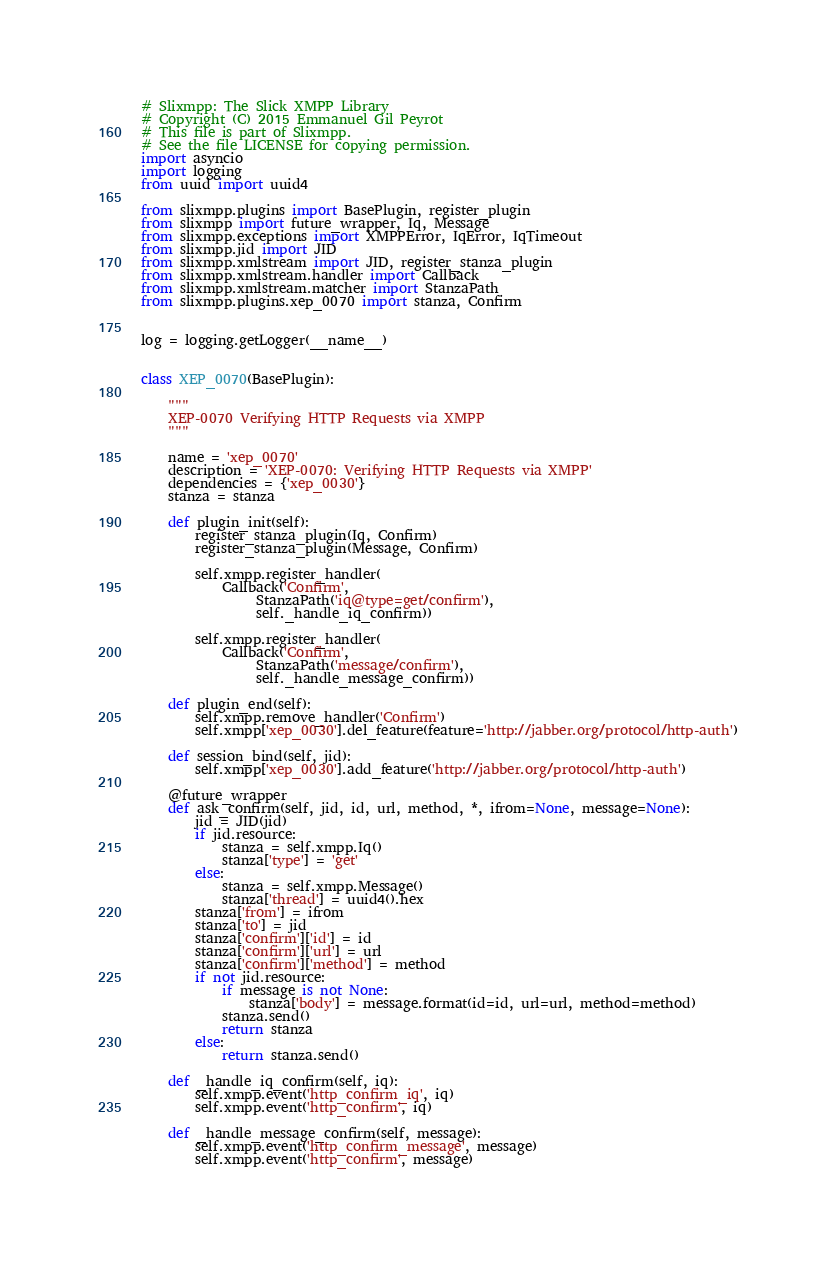Convert code to text. <code><loc_0><loc_0><loc_500><loc_500><_Python_>
# Slixmpp: The Slick XMPP Library
# Copyright (C) 2015 Emmanuel Gil Peyrot
# This file is part of Slixmpp.
# See the file LICENSE for copying permission.
import asyncio
import logging
from uuid import uuid4

from slixmpp.plugins import BasePlugin, register_plugin
from slixmpp import future_wrapper, Iq, Message
from slixmpp.exceptions import XMPPError, IqError, IqTimeout
from slixmpp.jid import JID
from slixmpp.xmlstream import JID, register_stanza_plugin
from slixmpp.xmlstream.handler import Callback
from slixmpp.xmlstream.matcher import StanzaPath
from slixmpp.plugins.xep_0070 import stanza, Confirm


log = logging.getLogger(__name__)


class XEP_0070(BasePlugin):

    """
    XEP-0070 Verifying HTTP Requests via XMPP
    """

    name = 'xep_0070'
    description = 'XEP-0070: Verifying HTTP Requests via XMPP'
    dependencies = {'xep_0030'}
    stanza = stanza

    def plugin_init(self):
        register_stanza_plugin(Iq, Confirm)
        register_stanza_plugin(Message, Confirm)

        self.xmpp.register_handler(
            Callback('Confirm',
                 StanzaPath('iq@type=get/confirm'),
                 self._handle_iq_confirm))

        self.xmpp.register_handler(
            Callback('Confirm',
                 StanzaPath('message/confirm'),
                 self._handle_message_confirm))

    def plugin_end(self):
        self.xmpp.remove_handler('Confirm')
        self.xmpp['xep_0030'].del_feature(feature='http://jabber.org/protocol/http-auth')

    def session_bind(self, jid):
        self.xmpp['xep_0030'].add_feature('http://jabber.org/protocol/http-auth')

    @future_wrapper
    def ask_confirm(self, jid, id, url, method, *, ifrom=None, message=None):
        jid = JID(jid)
        if jid.resource:
            stanza = self.xmpp.Iq()
            stanza['type'] = 'get'
        else:
            stanza = self.xmpp.Message()
            stanza['thread'] = uuid4().hex
        stanza['from'] = ifrom
        stanza['to'] = jid
        stanza['confirm']['id'] = id
        stanza['confirm']['url'] = url
        stanza['confirm']['method'] = method
        if not jid.resource:
            if message is not None:
                stanza['body'] = message.format(id=id, url=url, method=method)
            stanza.send()
            return stanza
        else:
            return stanza.send()

    def _handle_iq_confirm(self, iq):
        self.xmpp.event('http_confirm_iq', iq)
        self.xmpp.event('http_confirm', iq)

    def _handle_message_confirm(self, message):
        self.xmpp.event('http_confirm_message', message)
        self.xmpp.event('http_confirm', message)
</code> 